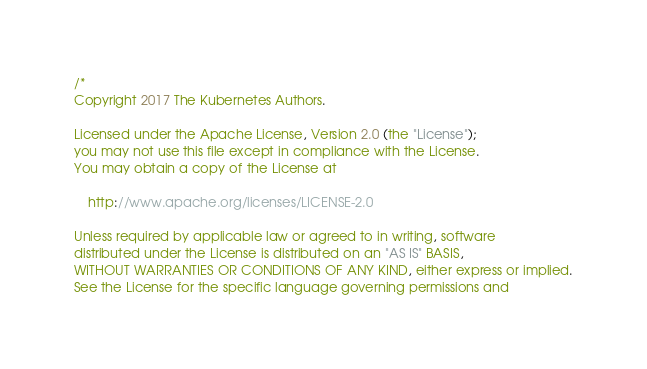Convert code to text. <code><loc_0><loc_0><loc_500><loc_500><_Go_>/*
Copyright 2017 The Kubernetes Authors.

Licensed under the Apache License, Version 2.0 (the "License");
you may not use this file except in compliance with the License.
You may obtain a copy of the License at

    http://www.apache.org/licenses/LICENSE-2.0

Unless required by applicable law or agreed to in writing, software
distributed under the License is distributed on an "AS IS" BASIS,
WITHOUT WARRANTIES OR CONDITIONS OF ANY KIND, either express or implied.
See the License for the specific language governing permissions and</code> 